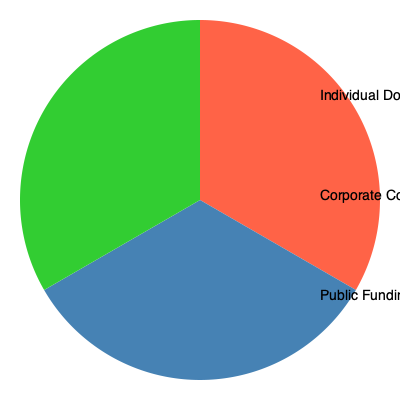Based on the pie chart showing Anthony Creevey's campaign funding sources, what percentage of the total funding came from individual donations and public funding combined? To solve this question, we need to follow these steps:

1. Identify the percentages for individual donations and public funding from the pie chart:
   - Individual Donations: 45%
   - Public Funding: 20%

2. Add these two percentages together:
   $45\% + 20\% = 65\%$

The combined percentage of funding from individual donations and public funding is 65% of the total campaign funding.

This calculation demonstrates that these two sources account for nearly two-thirds of Anthony Creevey's campaign funding, with individual donations being the largest single source of funding overall.
Answer: 65% 